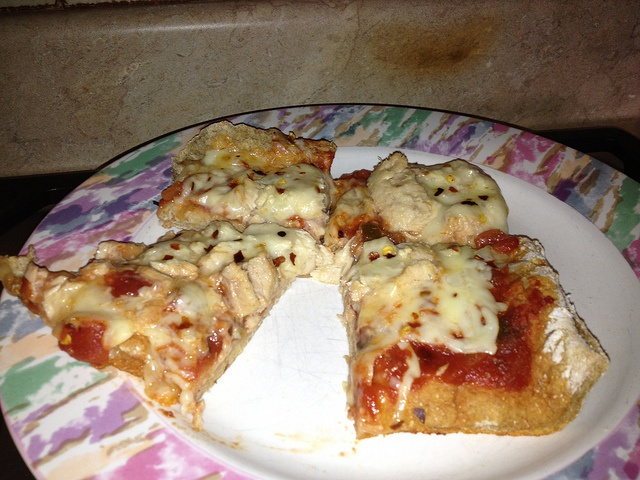Describe the objects in this image and their specific colors. I can see a pizza in black, tan, and olive tones in this image. 